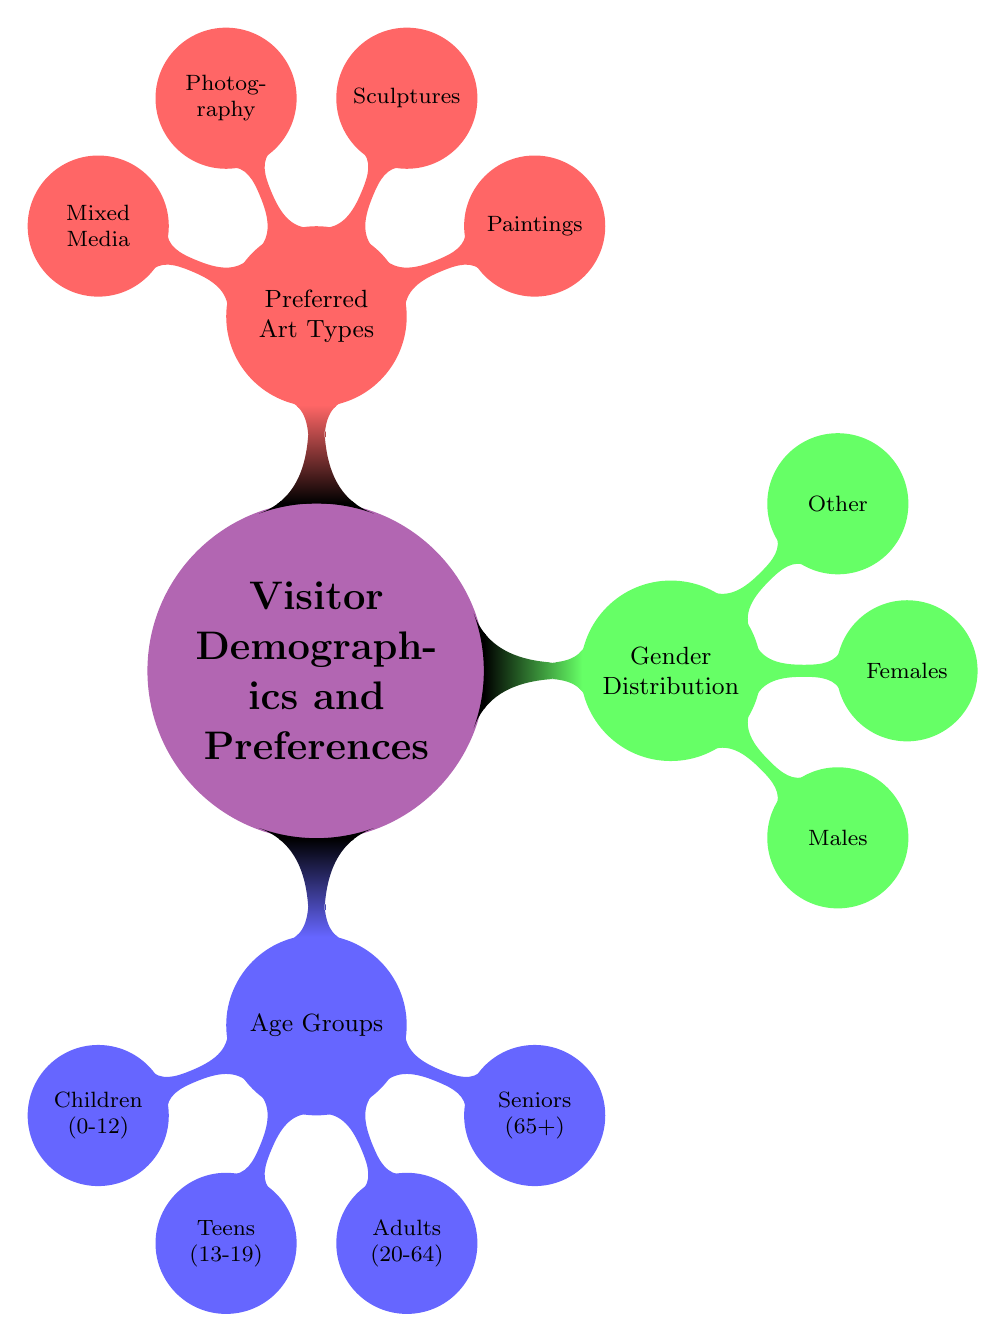What age group includes visitors aged 0 to 12? The diagram specifies that the "Children" age group (0-12) is a node under the "Age Groups" category. This can be found directly by locating the "Age Groups" node and identifying the children sub-node.
Answer: Children (0-12) How many age groups are listed in the diagram? The "Age Groups" node contains four child nodes: Children, Teens, Adults, and Seniors. Counting these nodes results in four distinct age groups.
Answer: 4 Which gender category is not explicitly male or female? Under the "Gender Distribution" section, there is a specific node labeled "Other," which captures visitors who identify outside of traditional male or female categories.
Answer: Other What is the preferred art type that involves three-dimensional works? The "Sculptures" node under "Preferred Art Types" represents three-dimensional artworks. Therefore, it is identified as the relevant preferred art type for this description.
Answer: Sculptures Which gender distribution has a node that most likely includes the majority of visitors? Between the gender categories listed, "Females" typically represents a significant portion of visitors in social studies of attendance, hence it is expected to be the most numerous in many galleries.
Answer: Females Which preferred art type is represented by a node that includes combinations of different media? The node labeled "Mixed Media" falls under the "Preferred Art Types" category and indicates a preference for artworks created using a combination of various materials and techniques.
Answer: Mixed Media What is the total number of gender categories represented in the diagram? The "Gender Distribution" section includes three child nodes: Males, Females, and Other. Summing these gives a total of three gender categories.
Answer: 3 How do age groups relate to preferred art types in the diagram? The diagram outlines "Age Groups" and "Preferred Art Types" as distinct branches without direct connections. Therefore, we can infer that each age group has varying interactions with the preferred art types, which are considered separately in the diagram.
Answer: No direct relationship 